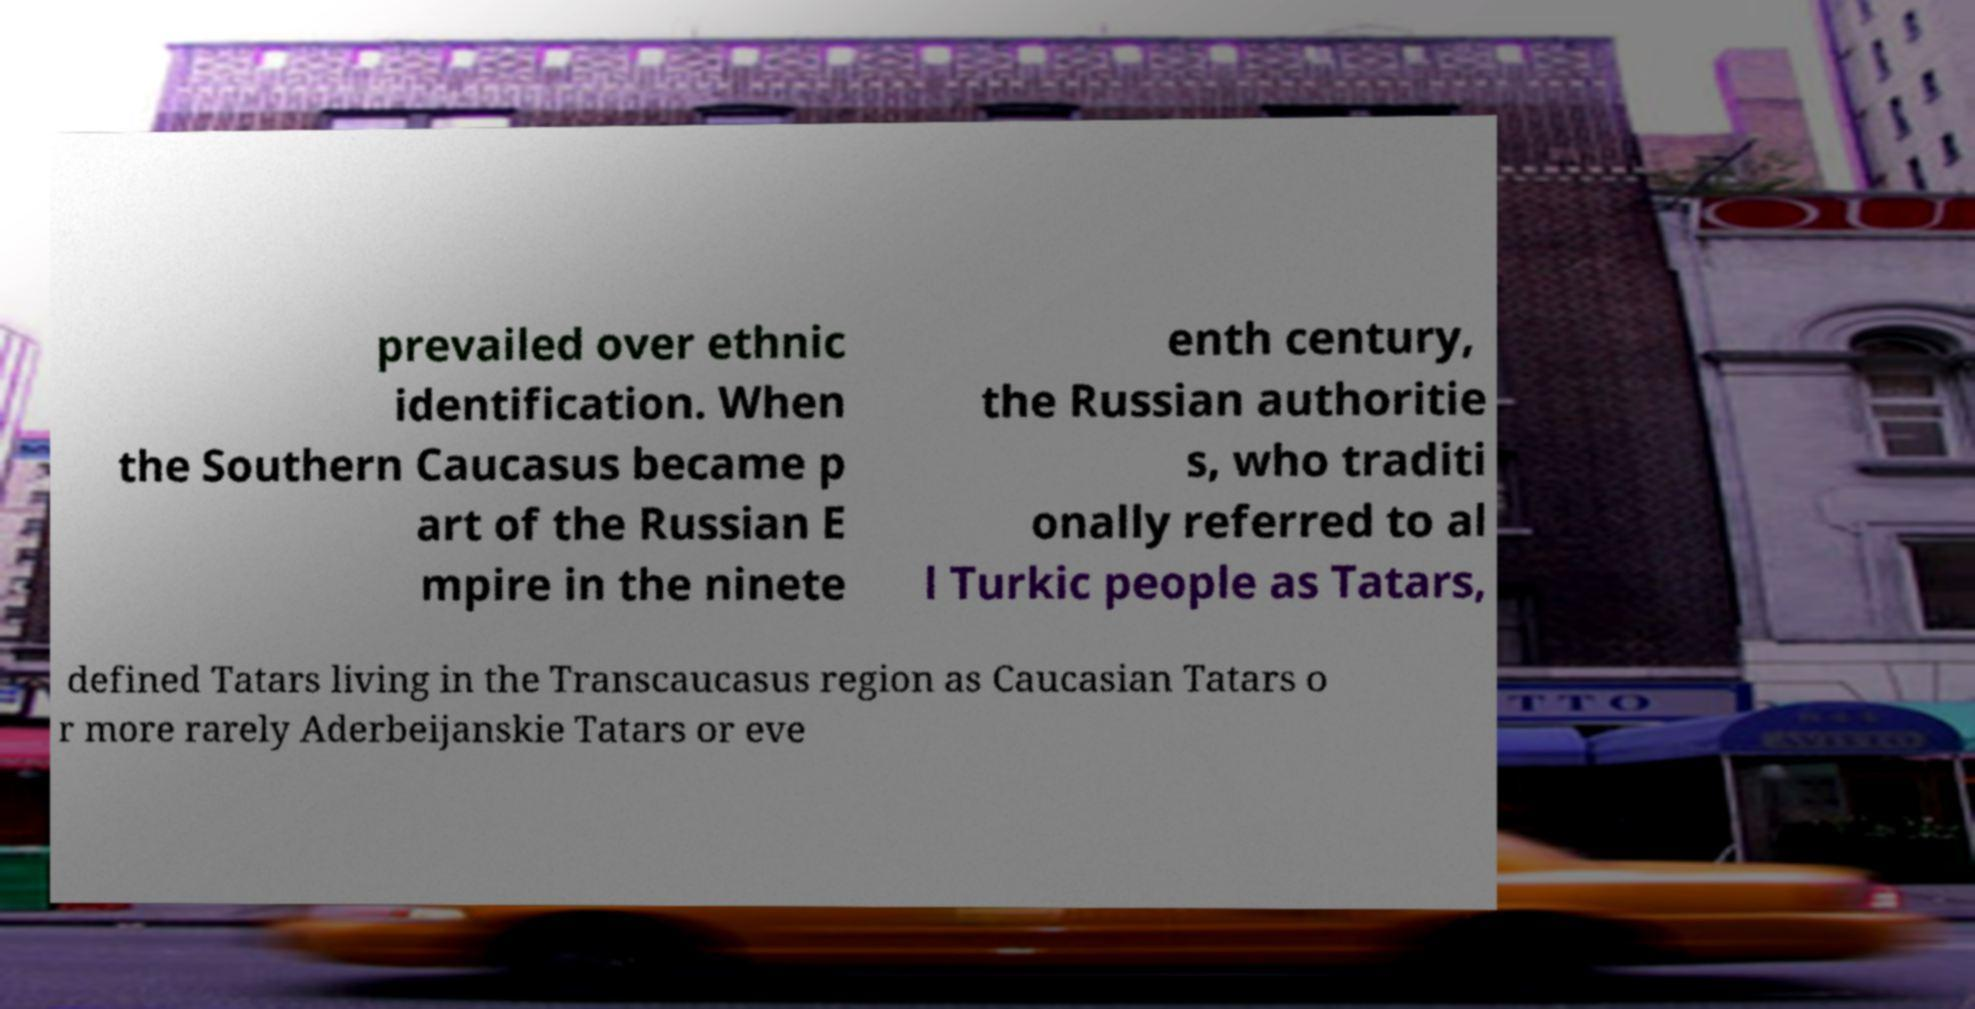There's text embedded in this image that I need extracted. Can you transcribe it verbatim? prevailed over ethnic identification. When the Southern Caucasus became p art of the Russian E mpire in the ninete enth century, the Russian authoritie s, who traditi onally referred to al l Turkic people as Tatars, defined Tatars living in the Transcaucasus region as Caucasian Tatars o r more rarely Aderbeijanskie Tatars or eve 